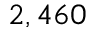Convert formula to latex. <formula><loc_0><loc_0><loc_500><loc_500>2 , 4 6 0</formula> 